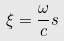<formula> <loc_0><loc_0><loc_500><loc_500>\xi = \frac { \omega } { c } s</formula> 